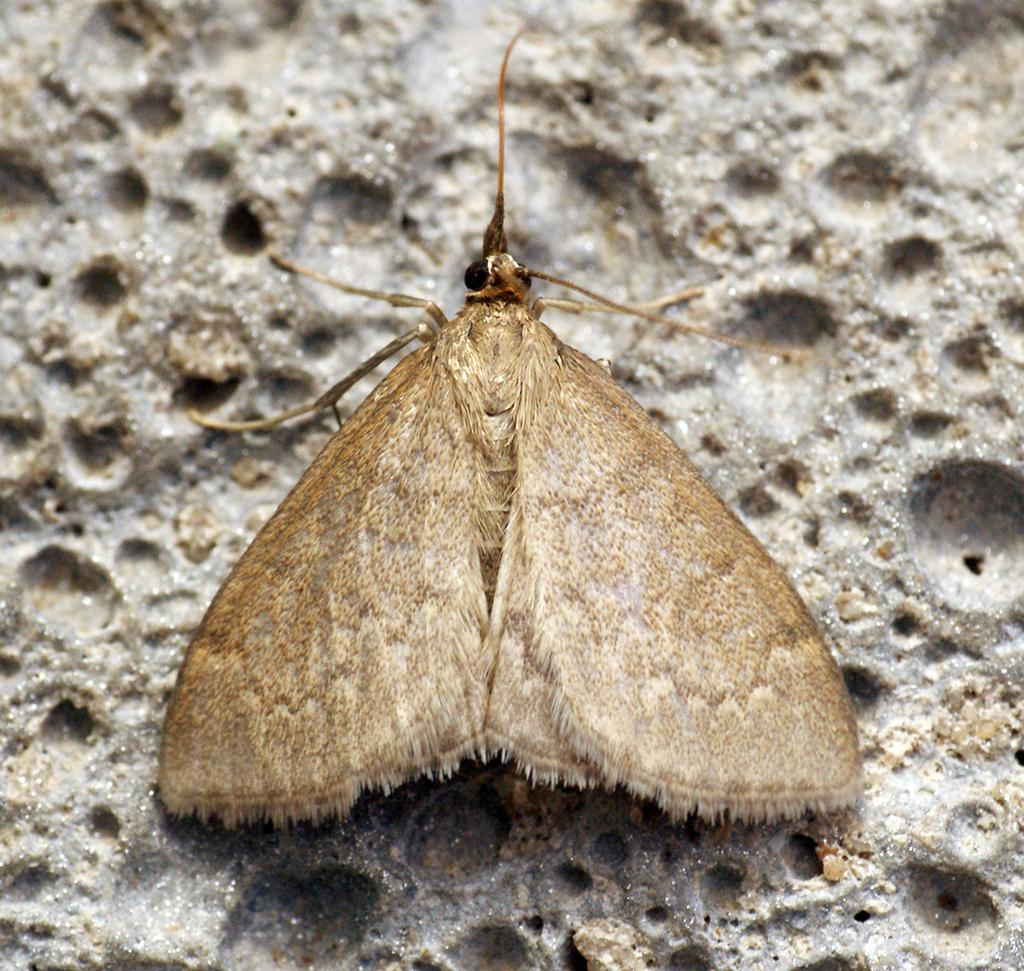What is present on the ground in the image? There is a fly on the ground in the image. What type of shade does the fly provide in the image? The fly does not provide any shade in the image, as it is a small insect and not capable of creating shade. 